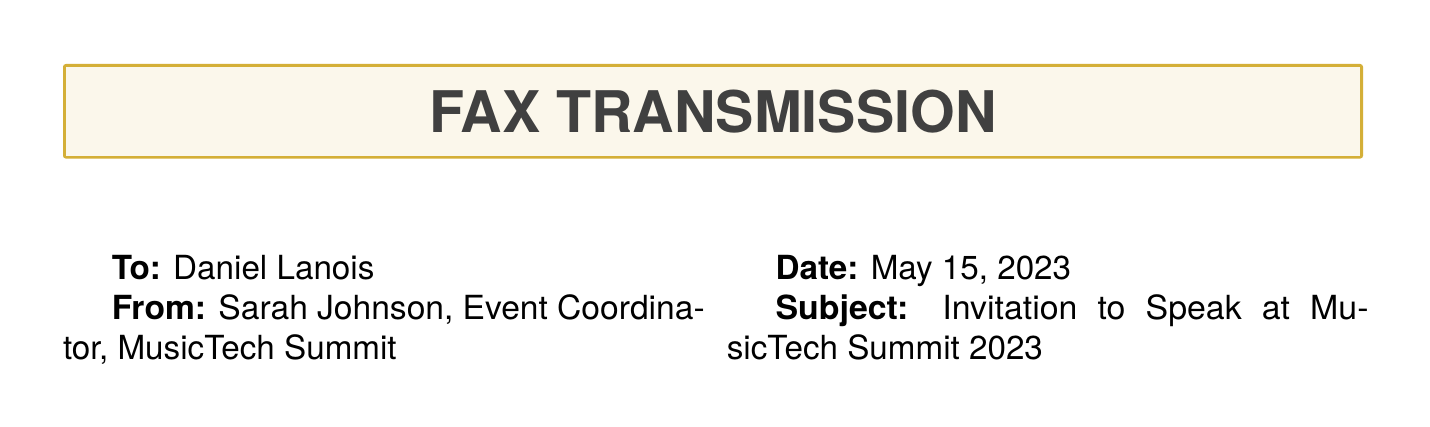What are the dates of the MusicTech Summit 2023? The dates of the event are specified in the document as September 12-14, 2023.
Answer: September 12-14, 2023 What is the topic of Daniel Lanois's speaking slot? The topic is mentioned as "Producing in the Digital Age: Lessons from U2 Collaborations."
Answer: Producing in the Digital Age: Lessons from U2 Collaborations Who is the sender of the fax? The sender's details are provided in the document, listing Sarah Johnson as the Event Coordinator.
Answer: Sarah Johnson What is the honorarium amount for speaking? The document states the honorarium as "$10,000 speaking fee."
Answer: $10,000 What is the RSVP deadline? The deadline for RSVPs is clearly stated as June 15, 2023.
Answer: June 15, 2023 What type of accommodation is provided? The document mentions the accommodation as Four Seasons Hotel San Francisco.
Answer: Four Seasons Hotel San Francisco On which date is Daniel Lanois scheduled to speak? The specific date for the speaking slot is mentioned as September 13, 2023.
Answer: September 13, 2023 What transportation service is mentioned for the event? The document indicates a private car service for all event-related travel.
Answer: Private car service 